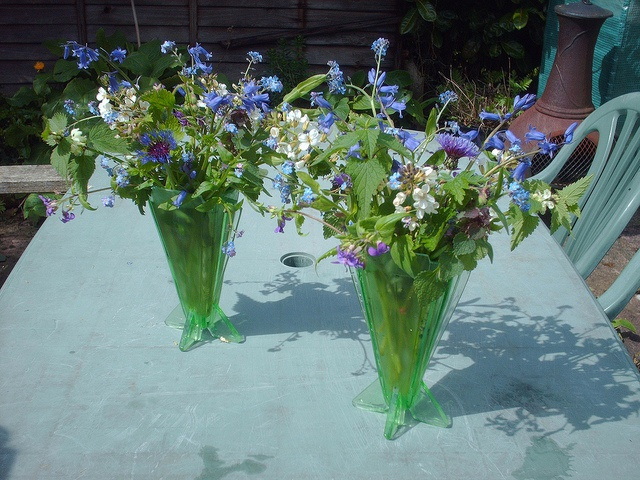Describe the objects in this image and their specific colors. I can see dining table in black, darkgray, lightblue, and gray tones, potted plant in black, darkgreen, and green tones, potted plant in black, darkgreen, and darkgray tones, vase in black, darkgreen, green, and teal tones, and chair in black, teal, and darkgray tones in this image. 